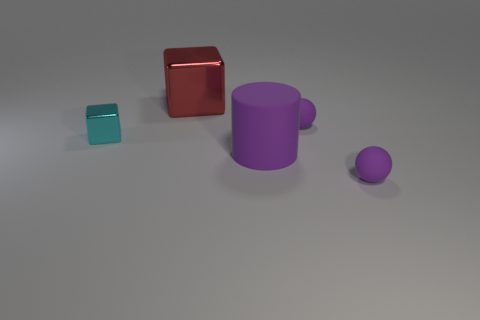Add 2 cyan things. How many objects exist? 7 Subtract all cubes. How many objects are left? 3 Subtract 1 cylinders. How many cylinders are left? 0 Subtract all rubber things. Subtract all blocks. How many objects are left? 0 Add 3 shiny objects. How many shiny objects are left? 5 Add 1 big red metallic objects. How many big red metallic objects exist? 2 Subtract 0 red spheres. How many objects are left? 5 Subtract all brown cylinders. Subtract all purple spheres. How many cylinders are left? 1 Subtract all blue cylinders. How many yellow blocks are left? 0 